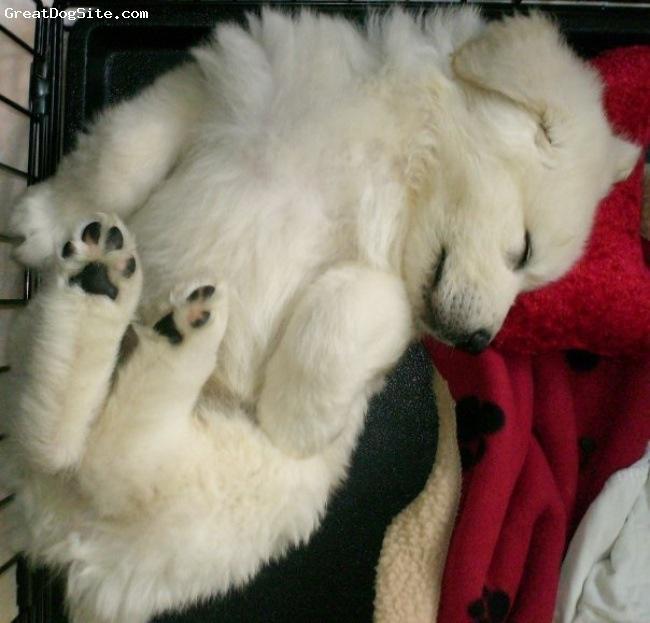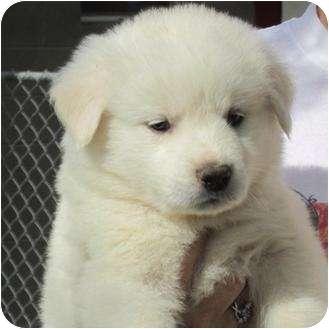The first image is the image on the left, the second image is the image on the right. Evaluate the accuracy of this statement regarding the images: "The dog in only one of the images has its eyes open.". Is it true? Answer yes or no. Yes. The first image is the image on the left, the second image is the image on the right. Evaluate the accuracy of this statement regarding the images: "A bright red plush item is next to the head of the dog in one image.". Is it true? Answer yes or no. Yes. 